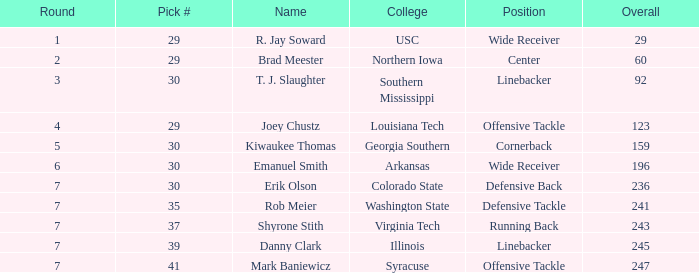What is the average Round for wide receiver r. jay soward and Overall smaller than 29? None. 